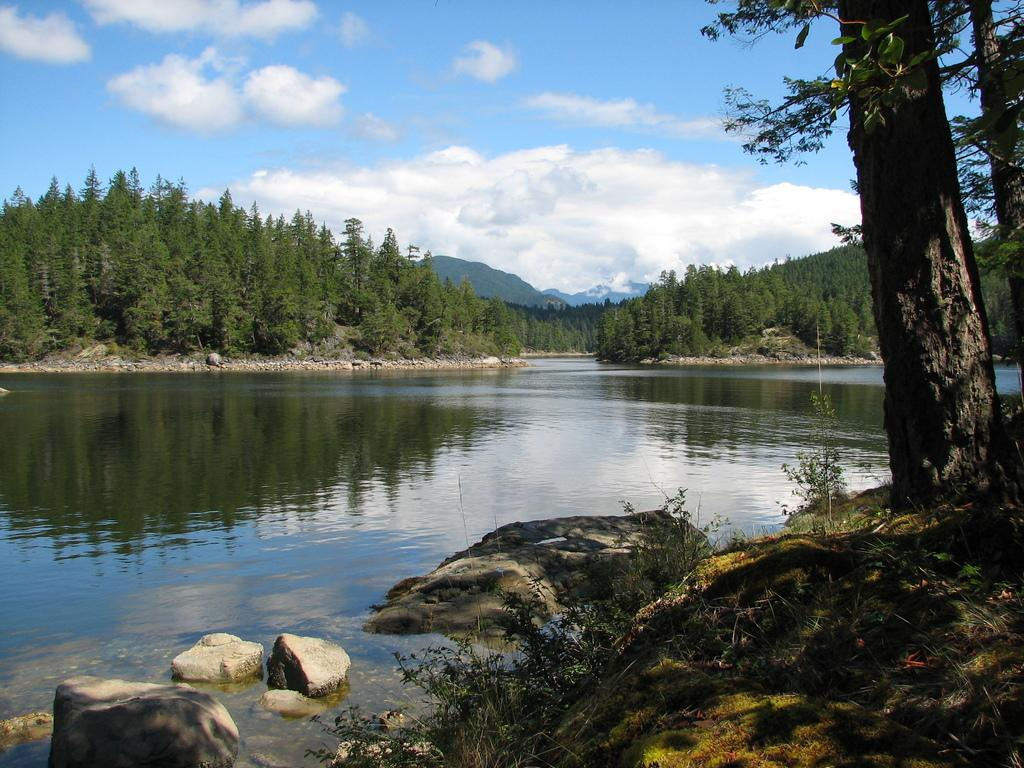What is visible in the sky in the image? The sky with clouds is visible in the image. What type of vegetation can be seen in the image? There are trees in the image. What type of natural formations are present in the image? Stones, hills, and rocks are visible in the image. What other natural elements can be seen in the image? Twigs are present in the image. What body of water is visible in the image? There is a lake in the image. Can you hear the thunder in the image? There is no sound present in the image, so it is not possible to hear thunder. What type of relation can be observed between the crow and the lake in the image? There is no crow present in the image, so it is not possible to observe any relation between a crow and the lake. 